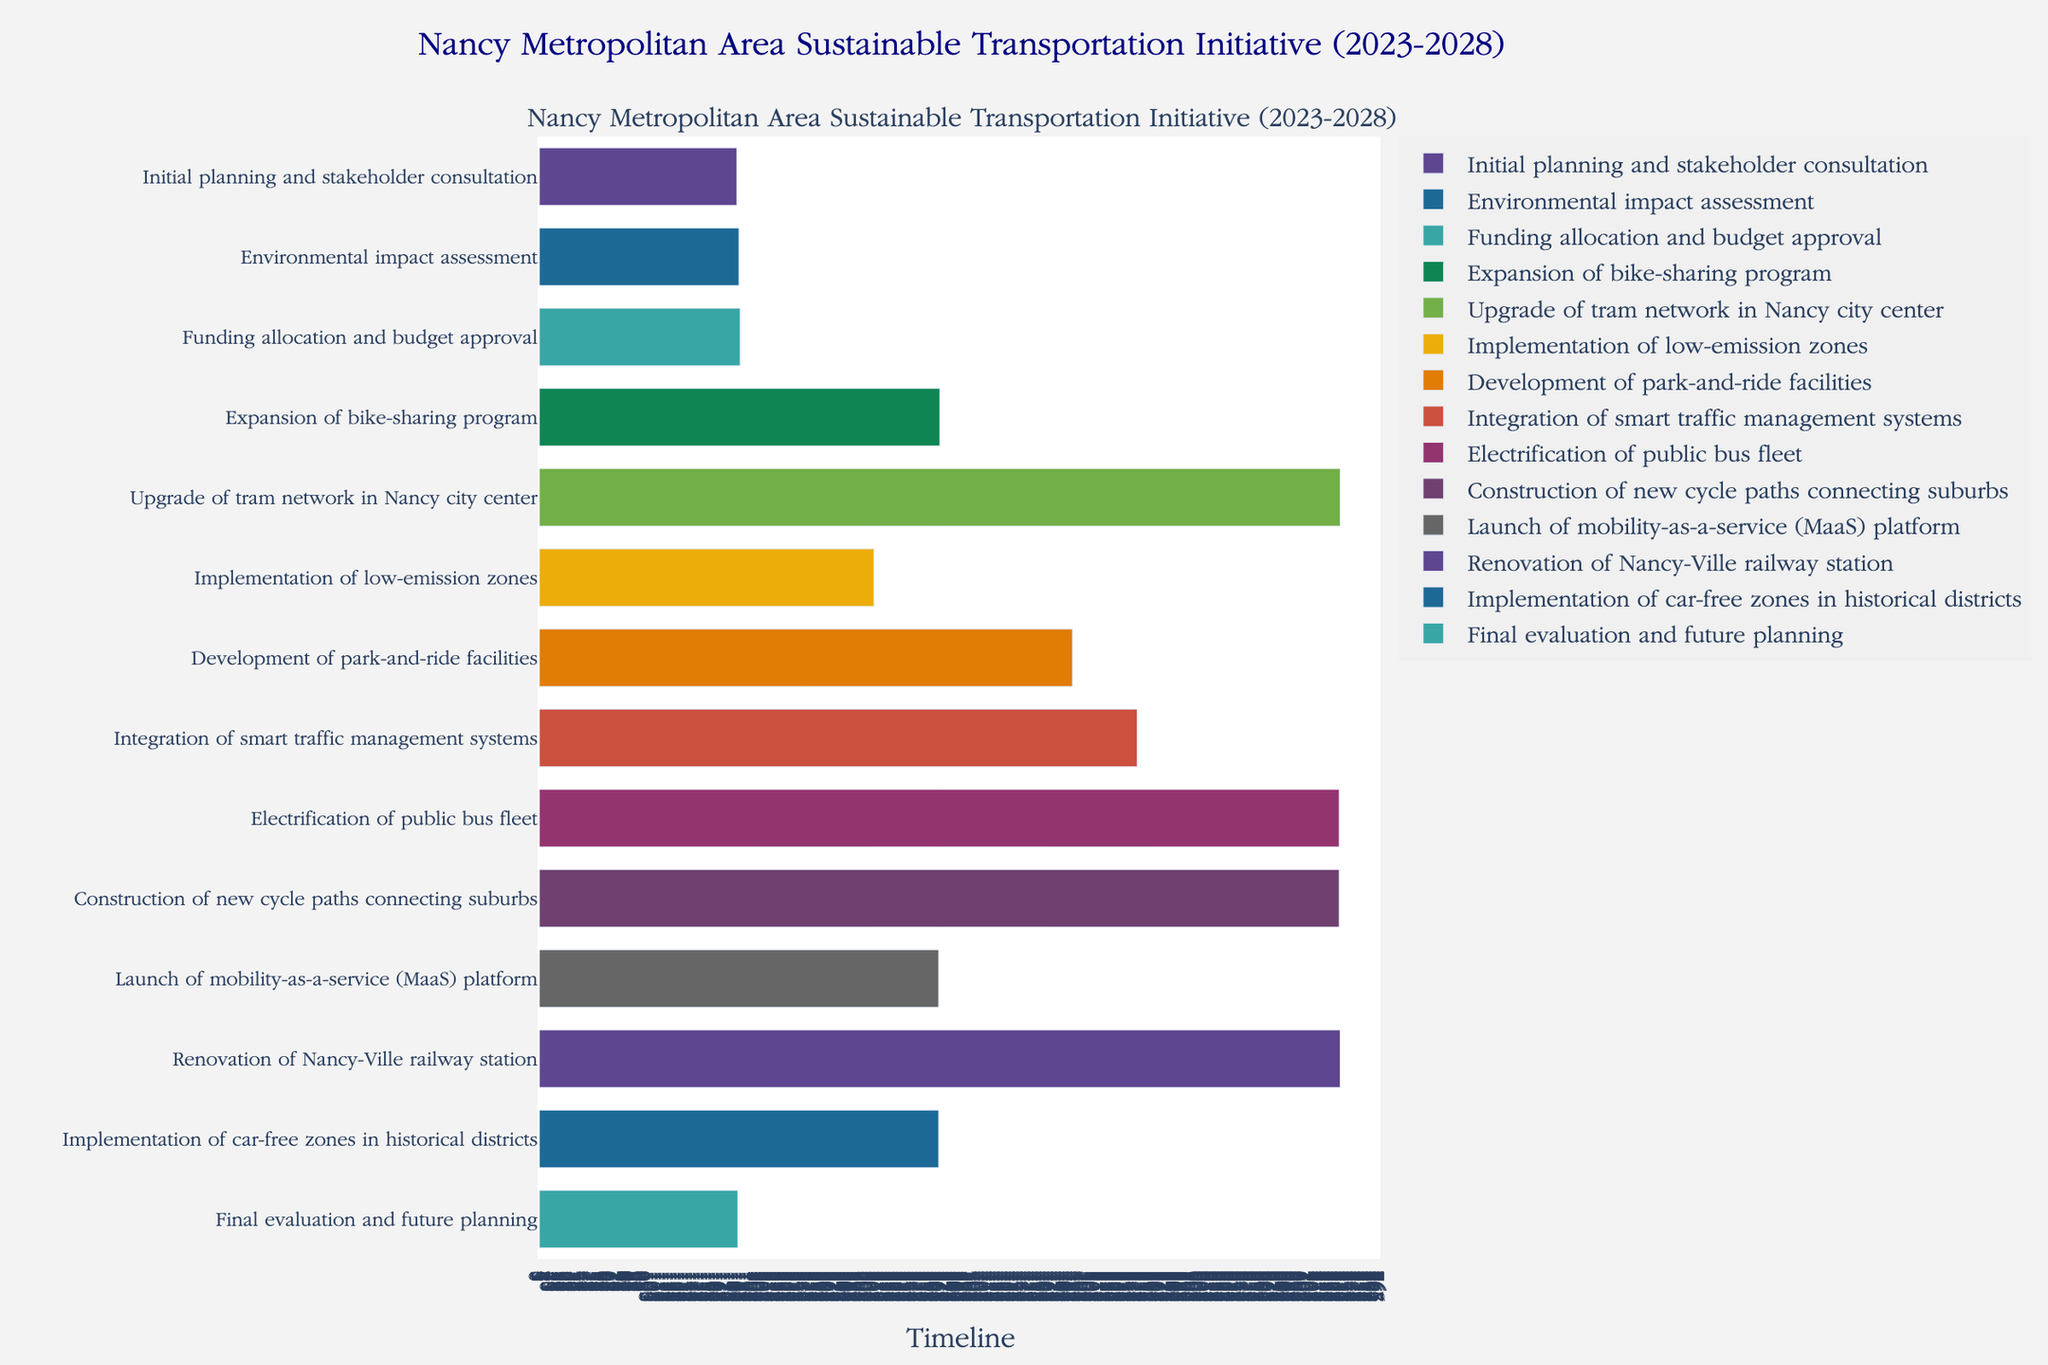What is the title of the Gantt chart? The title is found at the top of the chart and often provides context about what the chart is depicting. In this case, it gives an overview of the project timeline.
Answer: Nancy Metropolitan Area Sustainable Transportation Initiative (2023-2028) How many main tasks are represented in the chart? Count the number of unique tasks listed along the y-axis of the Gantt chart. Each task represents a significant part of the overall project.
Answer: 14 Which task has the longest duration? Compare the length of the bars representing each task to identify which one spans the most extended period from start to end dates.
Answer: Renovation of Nancy-Ville railway station When does the "Integration of smart traffic management systems" task begin and end? Locate the bar corresponding to this task and refer to its position to determine the start and end points.
Answer: Start: 2025-01-01, End: 2026-06-30 How many months does the "Funding allocation and budget approval" task span? Calculate the total time from the start date to the end date of the task and convert this period into months.
Answer: 6 months What tasks overlap with the "Development of park-and-ride facilities"? Identify tasks whose duration bars intersect with the "Development of park-and-ride facilities" bar by observing their start and end dates relative to each other.
Answer: Integration of smart traffic management systems, Electrification of public bus fleet What months and year does the last task, "Final evaluation and future planning", start and finish? Look at the position and length of the bar representing the final task on the chart to deduce its start and end months/years.
Answer: Start: 2028-01, End: 2028-06 Which tasks are scheduled to start in 2024? Identify bars that start in the year 2024 by examining their start points to determine the corresponding tasks.
Answer: Upgrade of tram network in Nancy city center, Implementation of low-emission zones, Development of park-and-ride facilities Are any tasks scheduled to end in 2025? Review the end points of bars to see if any align with the year 2025, which indicates they are scheduled to finish in that year.
Answer: Upgrade of tram network in Nancy city center, Development of park-and-ride facilities When does the "Expansion of bike-sharing program" task end, and what task starts immediately afterward? Locate the "Expansion of bike-sharing program" end point and see which task's start point directly follows it on the chart.
Answer: Ends: 2024-08-31, Starts afterward: Upgrade of tram network in Nancy city center 